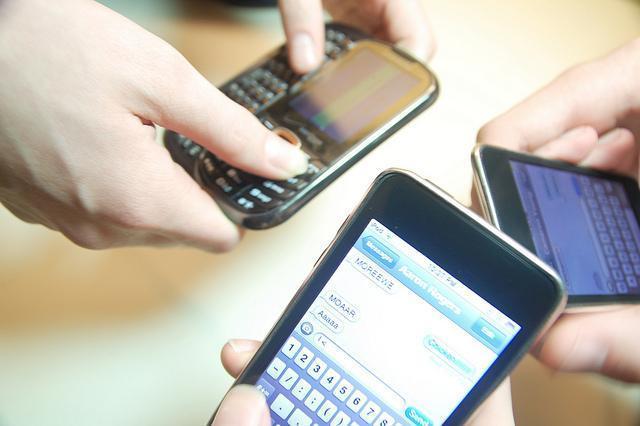How many phones do you see?
Give a very brief answer. 3. How many people are in the picture?
Give a very brief answer. 3. How many cell phones are there?
Give a very brief answer. 3. 